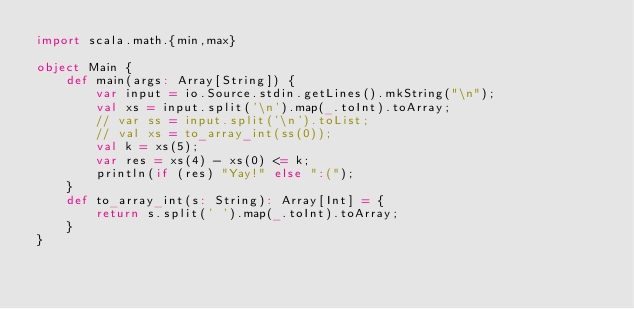Convert code to text. <code><loc_0><loc_0><loc_500><loc_500><_Scala_>import scala.math.{min,max}

object Main {
    def main(args: Array[String]) {
        var input = io.Source.stdin.getLines().mkString("\n");
        val xs = input.split('\n').map(_.toInt).toArray;
        // var ss = input.split('\n').toList;
        // val xs = to_array_int(ss(0));
        val k = xs(5);
        var res = xs(4) - xs(0) <= k;
        println(if (res) "Yay!" else ":(");
    }
    def to_array_int(s: String): Array[Int] = {
        return s.split(' ').map(_.toInt).toArray;
    }
}
</code> 